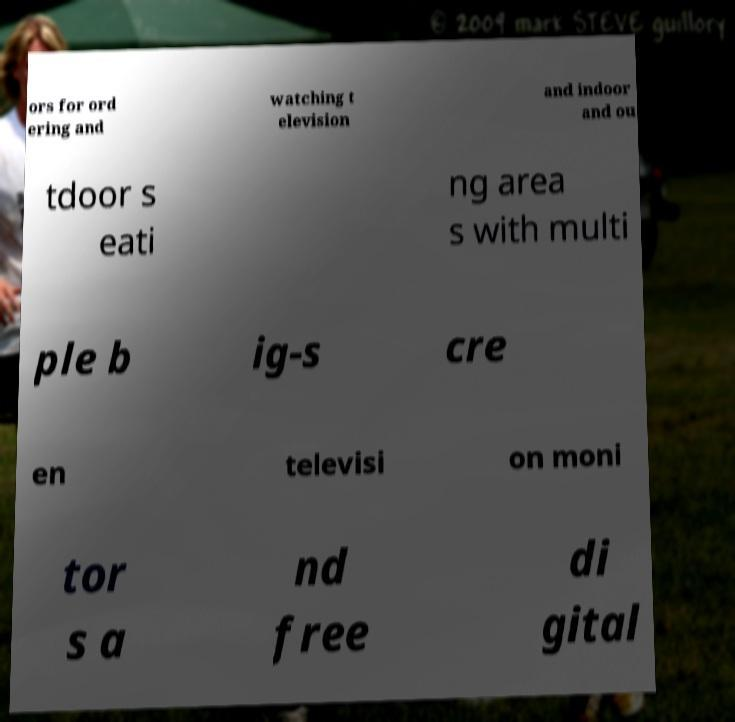Could you assist in decoding the text presented in this image and type it out clearly? ors for ord ering and watching t elevision and indoor and ou tdoor s eati ng area s with multi ple b ig-s cre en televisi on moni tor s a nd free di gital 